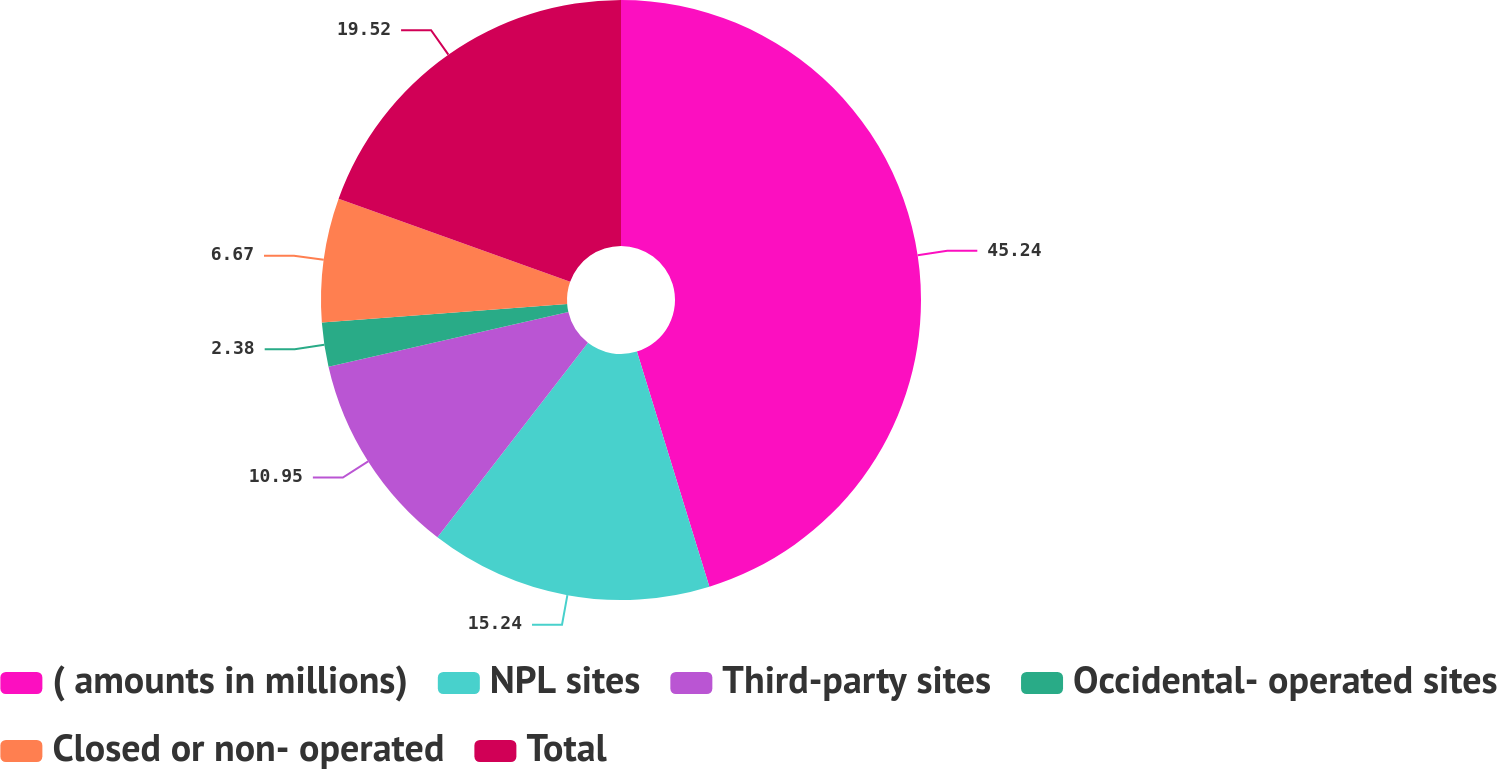Convert chart. <chart><loc_0><loc_0><loc_500><loc_500><pie_chart><fcel>( amounts in millions)<fcel>NPL sites<fcel>Third-party sites<fcel>Occidental- operated sites<fcel>Closed or non- operated<fcel>Total<nl><fcel>45.24%<fcel>15.24%<fcel>10.95%<fcel>2.38%<fcel>6.67%<fcel>19.52%<nl></chart> 